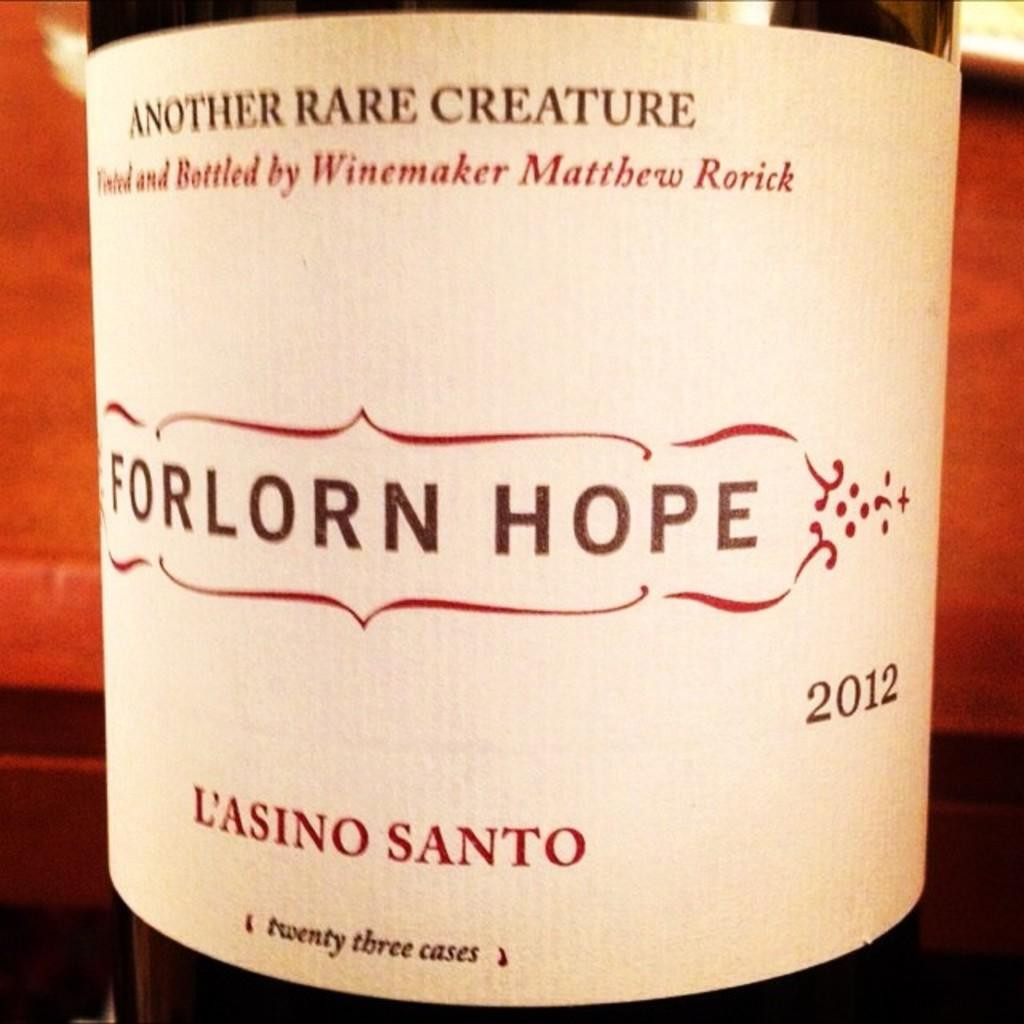Provide a one-sentence caption for the provided image. A 2012 bottle of wine is dubiously named Forlorn Hope. 